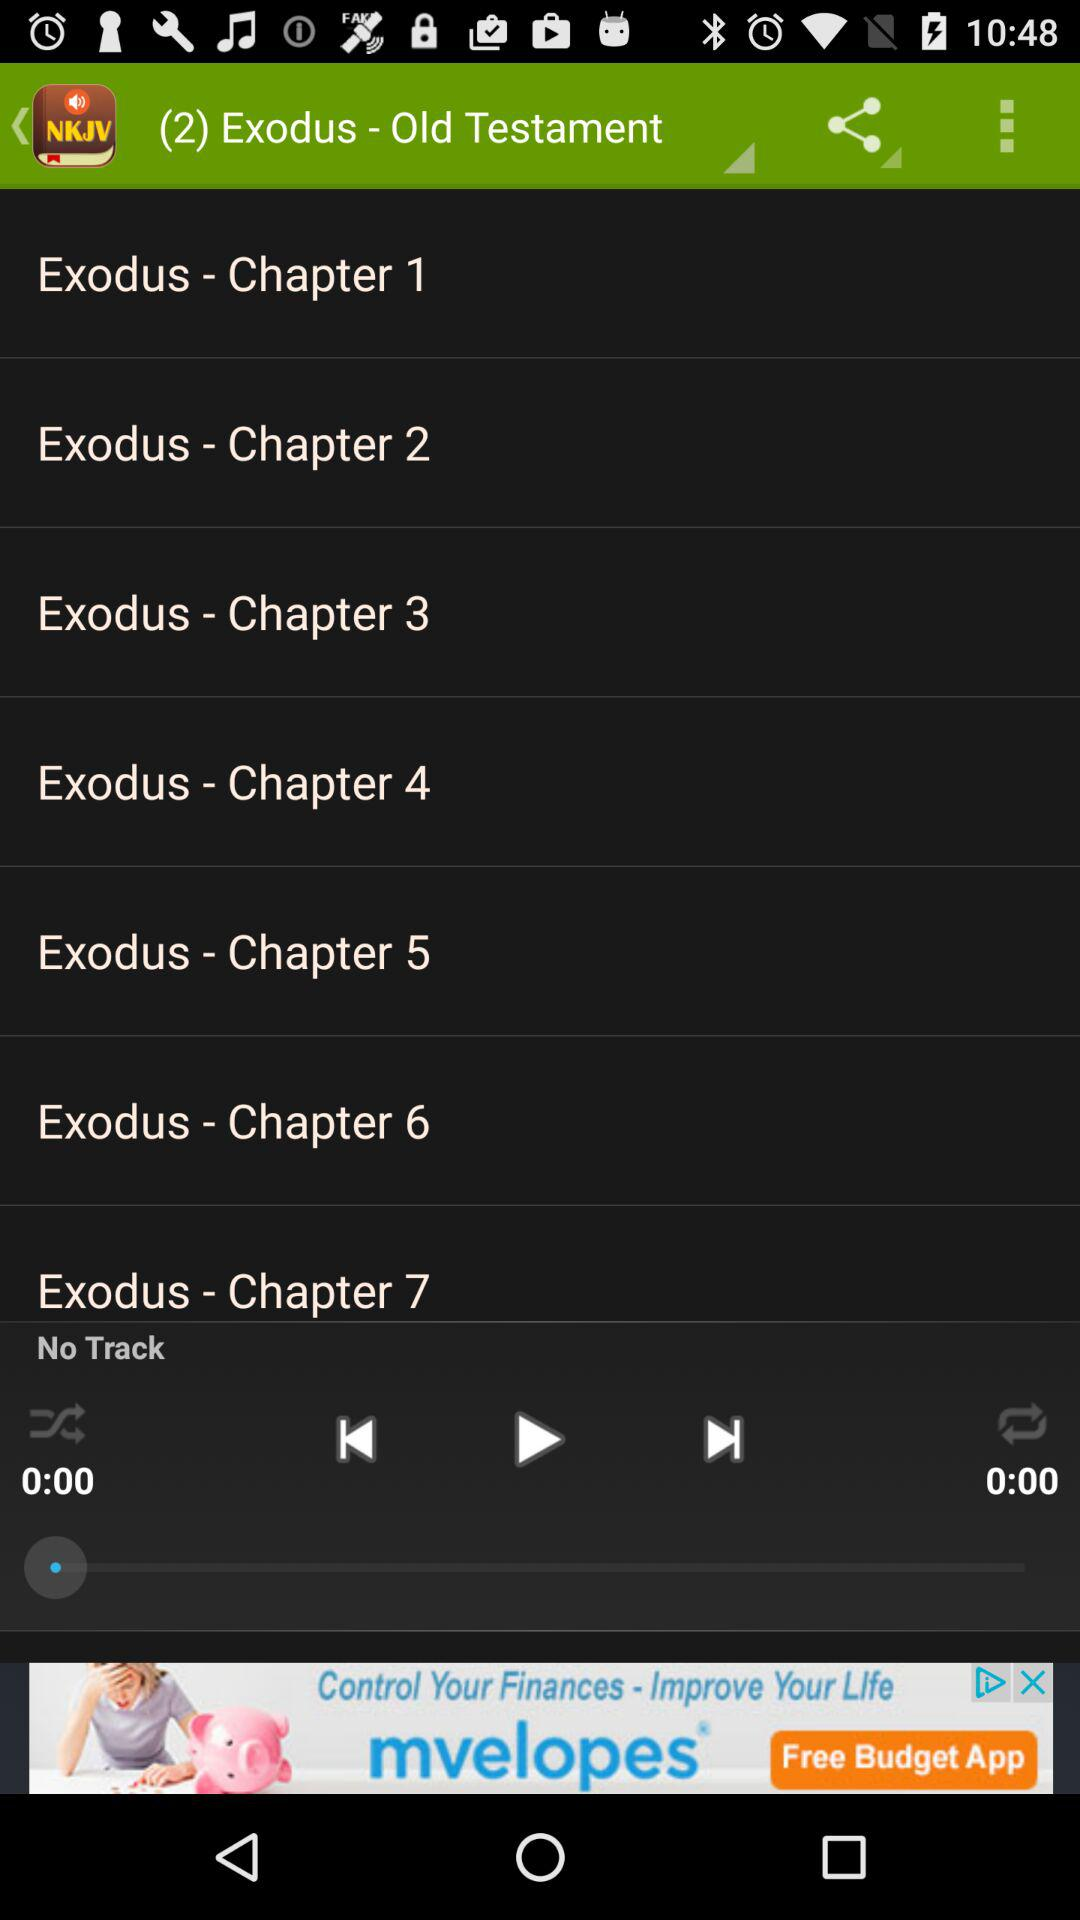Is there any track? There is no track. 